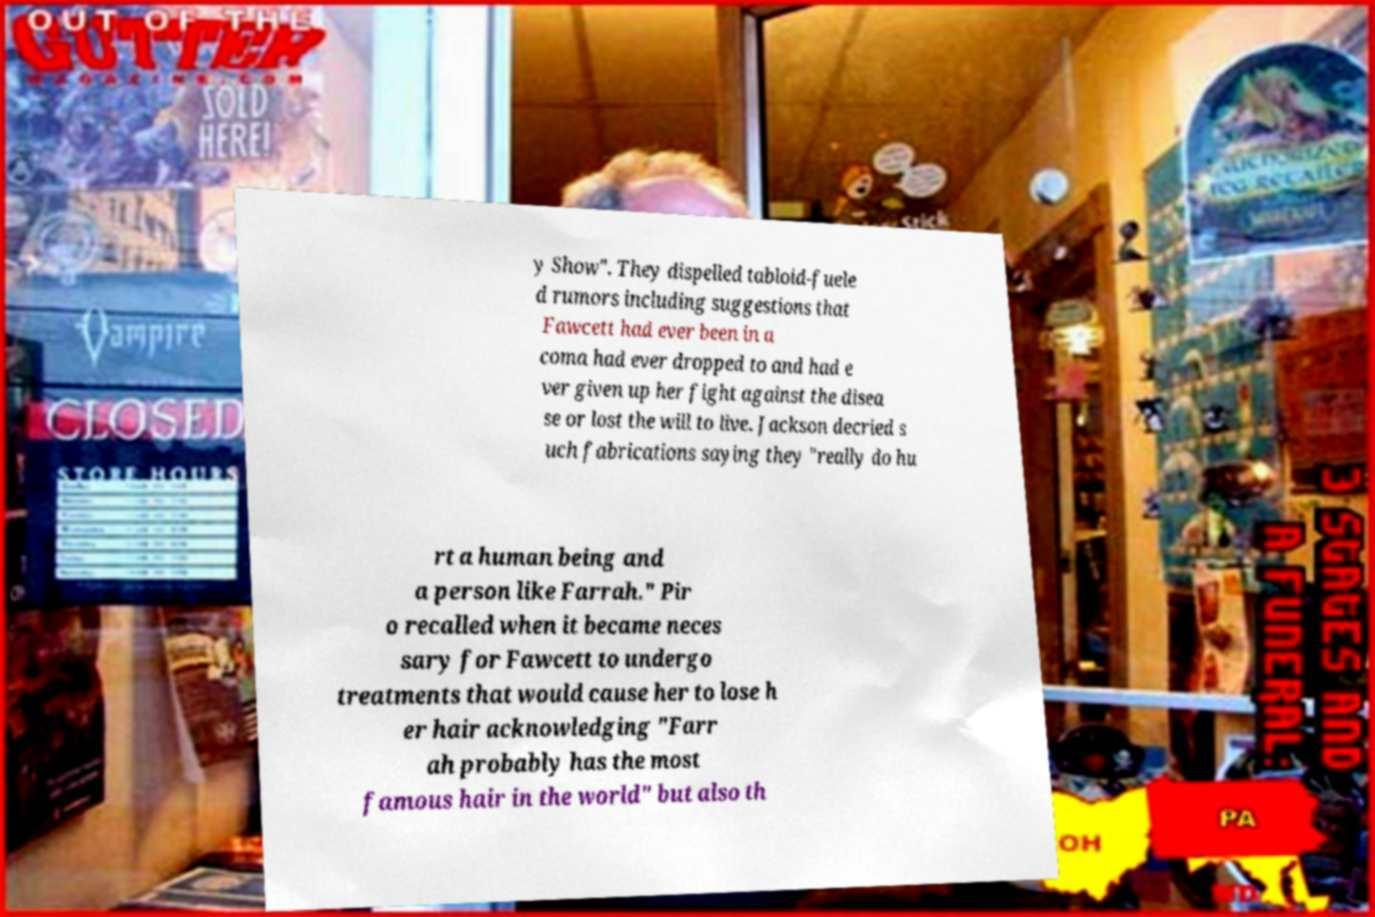Please identify and transcribe the text found in this image. y Show". They dispelled tabloid-fuele d rumors including suggestions that Fawcett had ever been in a coma had ever dropped to and had e ver given up her fight against the disea se or lost the will to live. Jackson decried s uch fabrications saying they "really do hu rt a human being and a person like Farrah." Pir o recalled when it became neces sary for Fawcett to undergo treatments that would cause her to lose h er hair acknowledging "Farr ah probably has the most famous hair in the world" but also th 